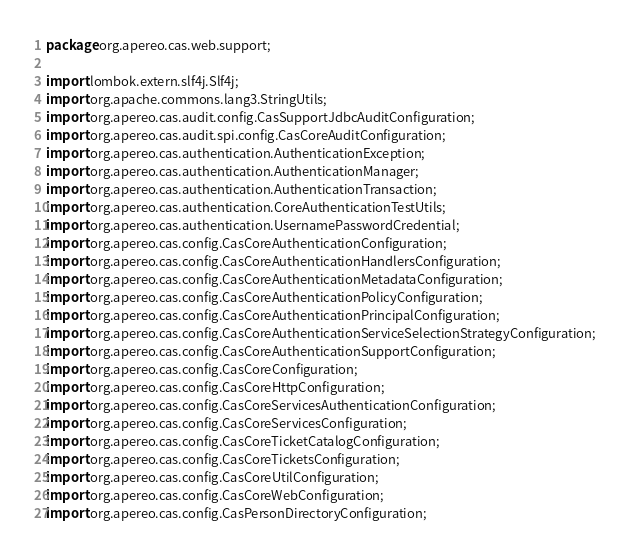Convert code to text. <code><loc_0><loc_0><loc_500><loc_500><_Java_>package org.apereo.cas.web.support;

import lombok.extern.slf4j.Slf4j;
import org.apache.commons.lang3.StringUtils;
import org.apereo.cas.audit.config.CasSupportJdbcAuditConfiguration;
import org.apereo.cas.audit.spi.config.CasCoreAuditConfiguration;
import org.apereo.cas.authentication.AuthenticationException;
import org.apereo.cas.authentication.AuthenticationManager;
import org.apereo.cas.authentication.AuthenticationTransaction;
import org.apereo.cas.authentication.CoreAuthenticationTestUtils;
import org.apereo.cas.authentication.UsernamePasswordCredential;
import org.apereo.cas.config.CasCoreAuthenticationConfiguration;
import org.apereo.cas.config.CasCoreAuthenticationHandlersConfiguration;
import org.apereo.cas.config.CasCoreAuthenticationMetadataConfiguration;
import org.apereo.cas.config.CasCoreAuthenticationPolicyConfiguration;
import org.apereo.cas.config.CasCoreAuthenticationPrincipalConfiguration;
import org.apereo.cas.config.CasCoreAuthenticationServiceSelectionStrategyConfiguration;
import org.apereo.cas.config.CasCoreAuthenticationSupportConfiguration;
import org.apereo.cas.config.CasCoreConfiguration;
import org.apereo.cas.config.CasCoreHttpConfiguration;
import org.apereo.cas.config.CasCoreServicesAuthenticationConfiguration;
import org.apereo.cas.config.CasCoreServicesConfiguration;
import org.apereo.cas.config.CasCoreTicketCatalogConfiguration;
import org.apereo.cas.config.CasCoreTicketsConfiguration;
import org.apereo.cas.config.CasCoreUtilConfiguration;
import org.apereo.cas.config.CasCoreWebConfiguration;
import org.apereo.cas.config.CasPersonDirectoryConfiguration;</code> 